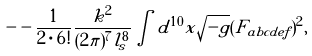<formula> <loc_0><loc_0><loc_500><loc_500>- - \frac { 1 } { 2 \cdot 6 ! } \frac { k ^ { 2 } } { ( 2 \pi ) ^ { 7 } l _ { s } ^ { 8 } } \int d ^ { 1 0 } x \sqrt { - g } ( F _ { a b c d e f } ) ^ { 2 } ,</formula> 